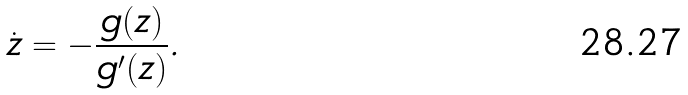Convert formula to latex. <formula><loc_0><loc_0><loc_500><loc_500>\dot { z } = - \frac { g ( z ) } { g ^ { \prime } ( z ) } .</formula> 